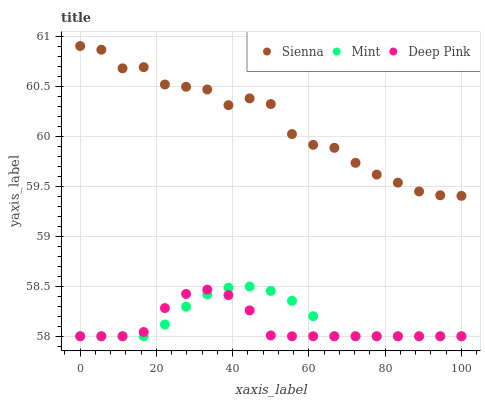Does Deep Pink have the minimum area under the curve?
Answer yes or no. Yes. Does Sienna have the maximum area under the curve?
Answer yes or no. Yes. Does Mint have the minimum area under the curve?
Answer yes or no. No. Does Mint have the maximum area under the curve?
Answer yes or no. No. Is Mint the smoothest?
Answer yes or no. Yes. Is Sienna the roughest?
Answer yes or no. Yes. Is Deep Pink the smoothest?
Answer yes or no. No. Is Deep Pink the roughest?
Answer yes or no. No. Does Deep Pink have the lowest value?
Answer yes or no. Yes. Does Sienna have the highest value?
Answer yes or no. Yes. Does Mint have the highest value?
Answer yes or no. No. Is Deep Pink less than Sienna?
Answer yes or no. Yes. Is Sienna greater than Mint?
Answer yes or no. Yes. Does Deep Pink intersect Mint?
Answer yes or no. Yes. Is Deep Pink less than Mint?
Answer yes or no. No. Is Deep Pink greater than Mint?
Answer yes or no. No. Does Deep Pink intersect Sienna?
Answer yes or no. No. 